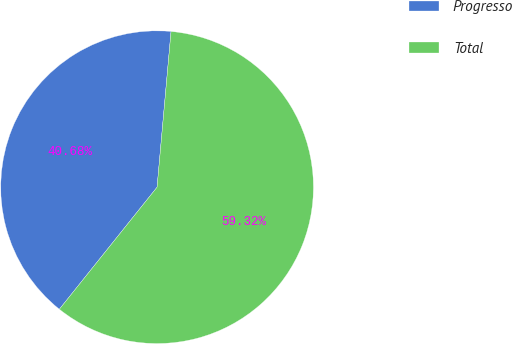<chart> <loc_0><loc_0><loc_500><loc_500><pie_chart><fcel>Progresso<fcel>Total<nl><fcel>40.68%<fcel>59.32%<nl></chart> 